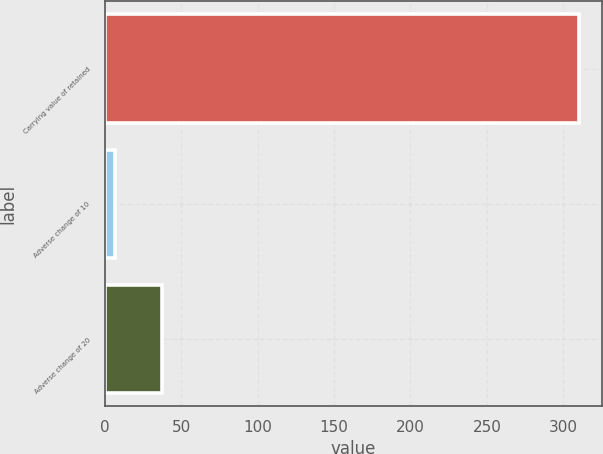Convert chart. <chart><loc_0><loc_0><loc_500><loc_500><bar_chart><fcel>Carrying value of retained<fcel>Adverse change of 10<fcel>Adverse change of 20<nl><fcel>310<fcel>7<fcel>37.3<nl></chart> 